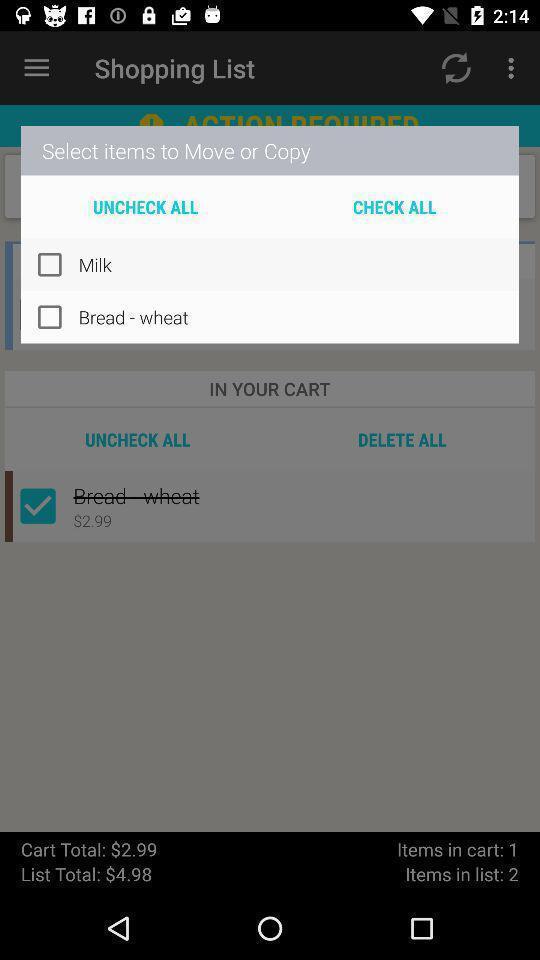What details can you identify in this image? Popup showing items to select. 